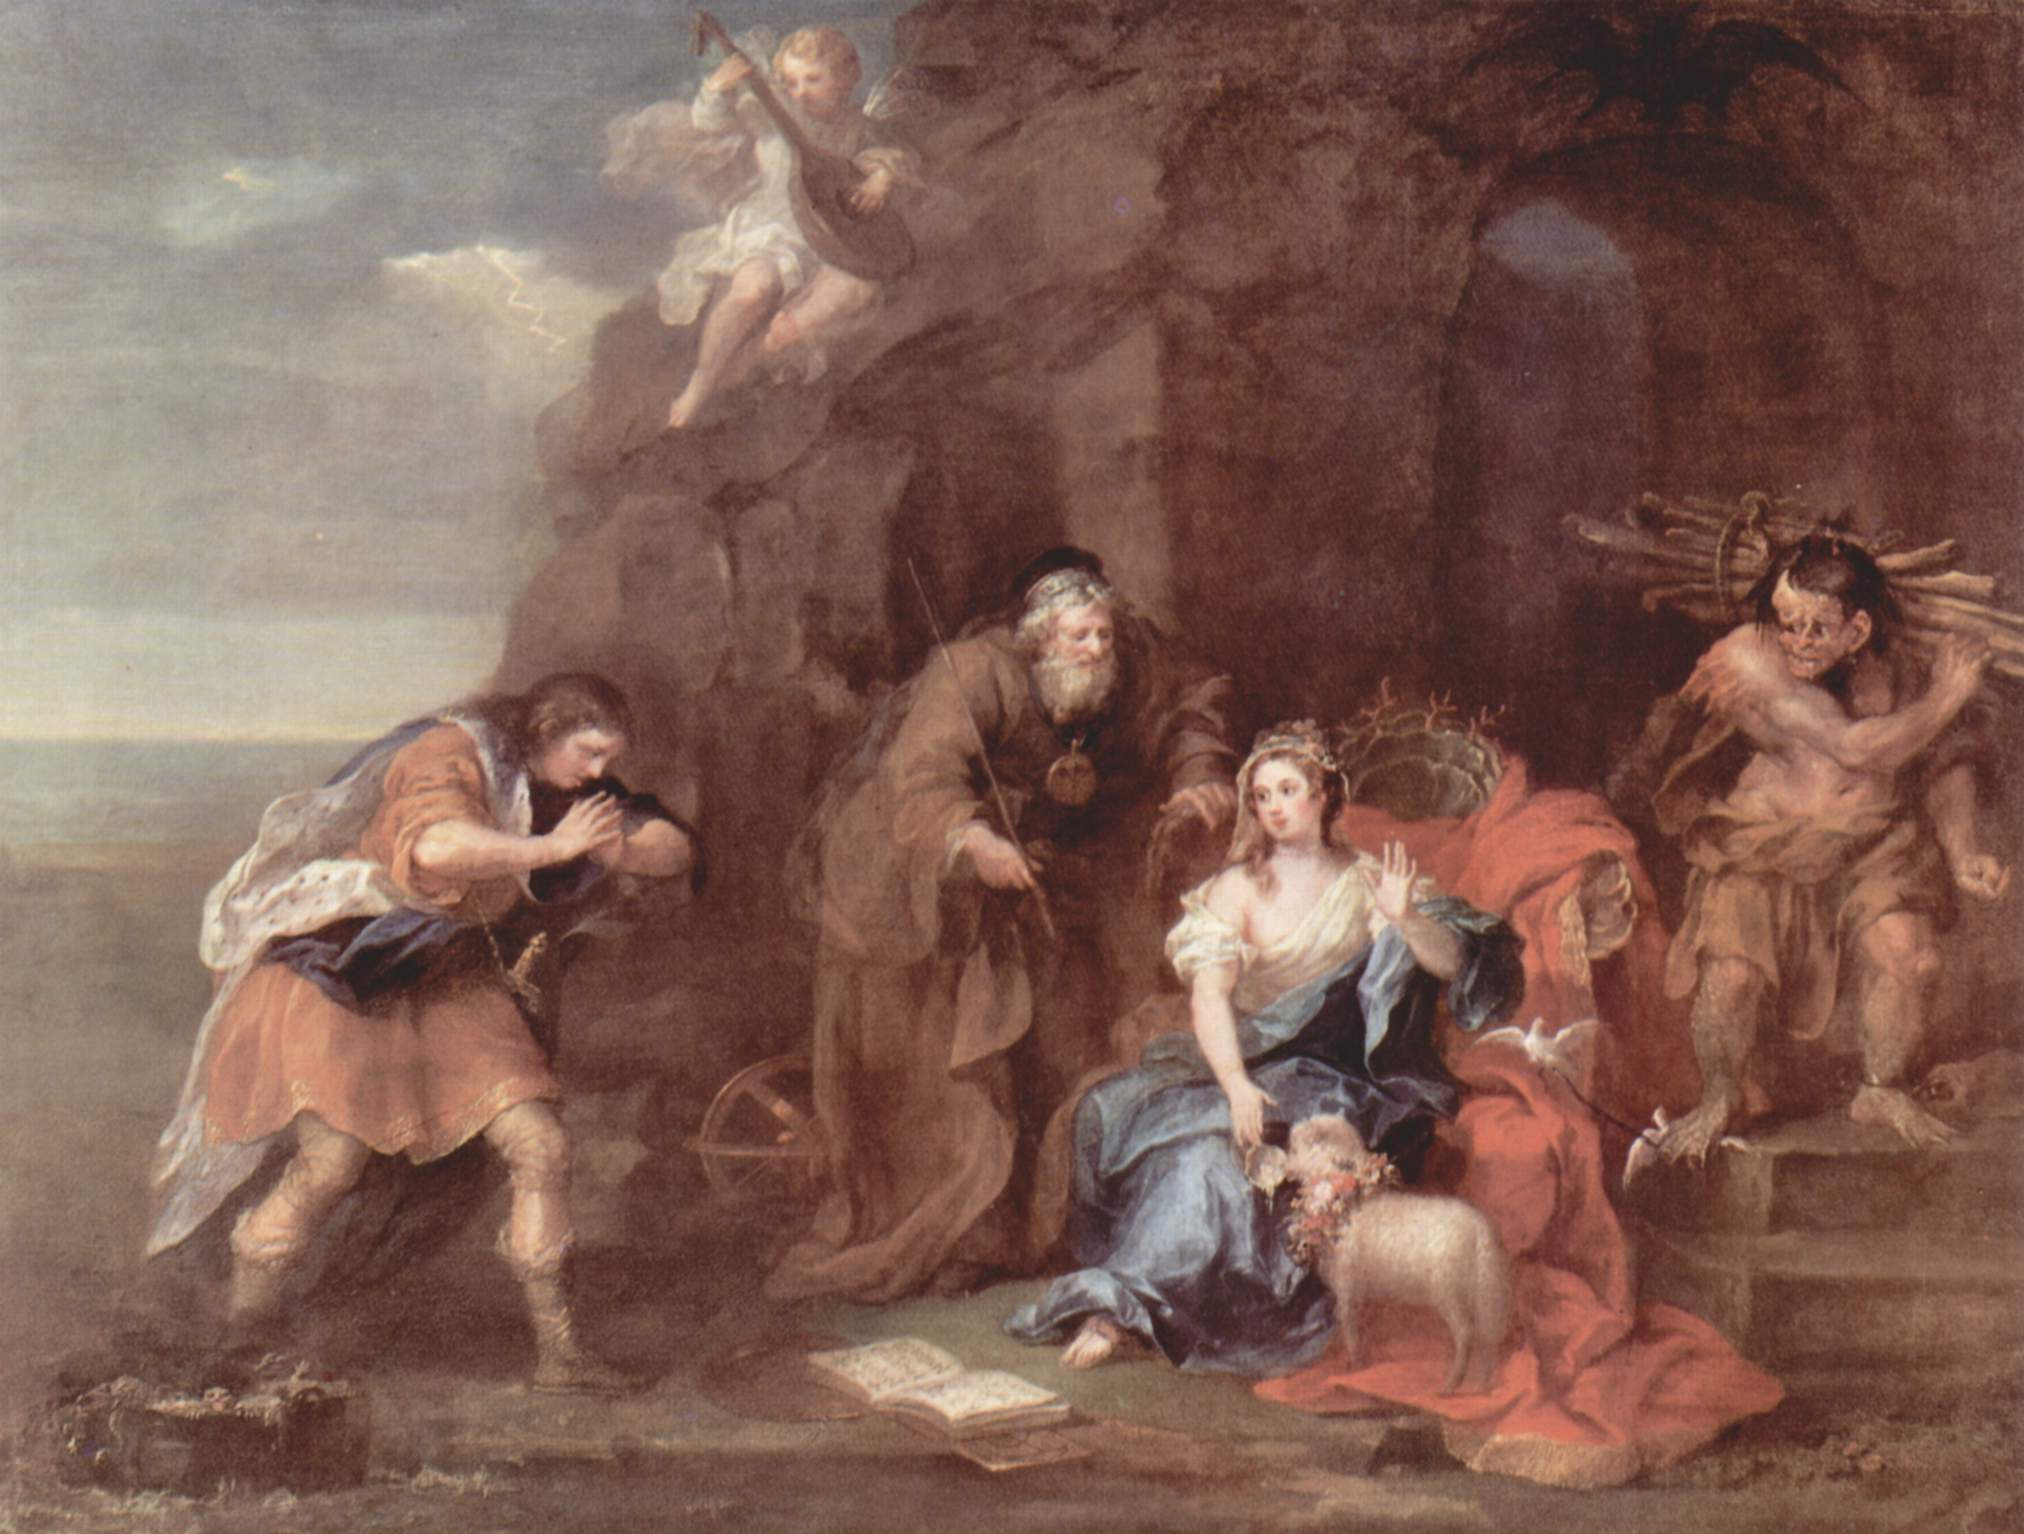If you were to name this painting, what would you call it and why? I would name this painting 'The Harmony of Wisdom and Divine Favor.' This title encapsulates the core elements and themes present in the artwork. 'Harmony' reflects the balanced coexistence of the figures and their actions—the reading, the music, the labor, and the divine presence of the cherubs. 'Wisdom' highlights the central figure's engagement with the book, signifying the pursuit of knowledge. 'Divine Favor' acknowledges the cherubic beings and the celebratory garland, symbolizing heavenly blessing and festivity. Together, the title conveys the painting's rich narrative and the interconnectedness of human and divine, intellect and emotion. 